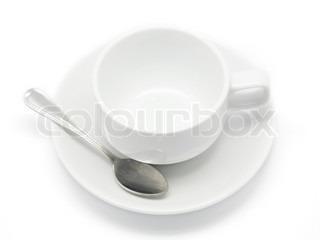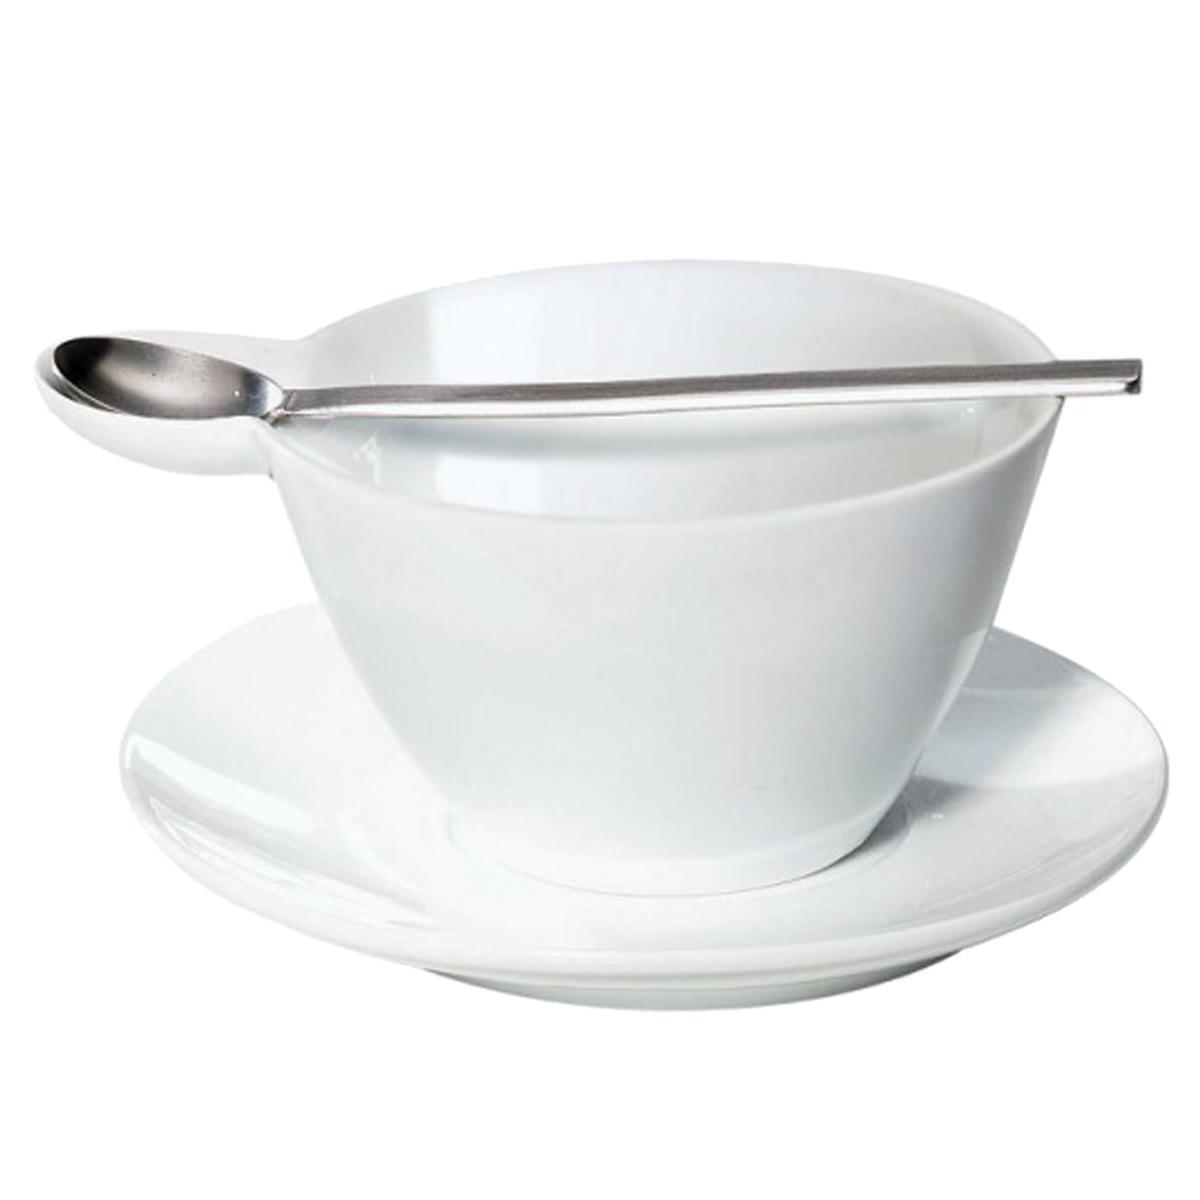The first image is the image on the left, the second image is the image on the right. For the images displayed, is the sentence "A spoon is resting on a saucer near a tea cup." factually correct? Answer yes or no. Yes. The first image is the image on the left, the second image is the image on the right. For the images shown, is this caption "There are three or more tea cups." true? Answer yes or no. No. 